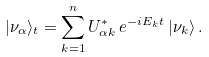Convert formula to latex. <formula><loc_0><loc_0><loc_500><loc_500>| \nu _ { \alpha } \rangle _ { t } = \sum _ { k = 1 } ^ { n } U _ { { \alpha } k } ^ { * } \, e ^ { - i E _ { k } t } \, | \nu _ { k } \rangle \, .</formula> 